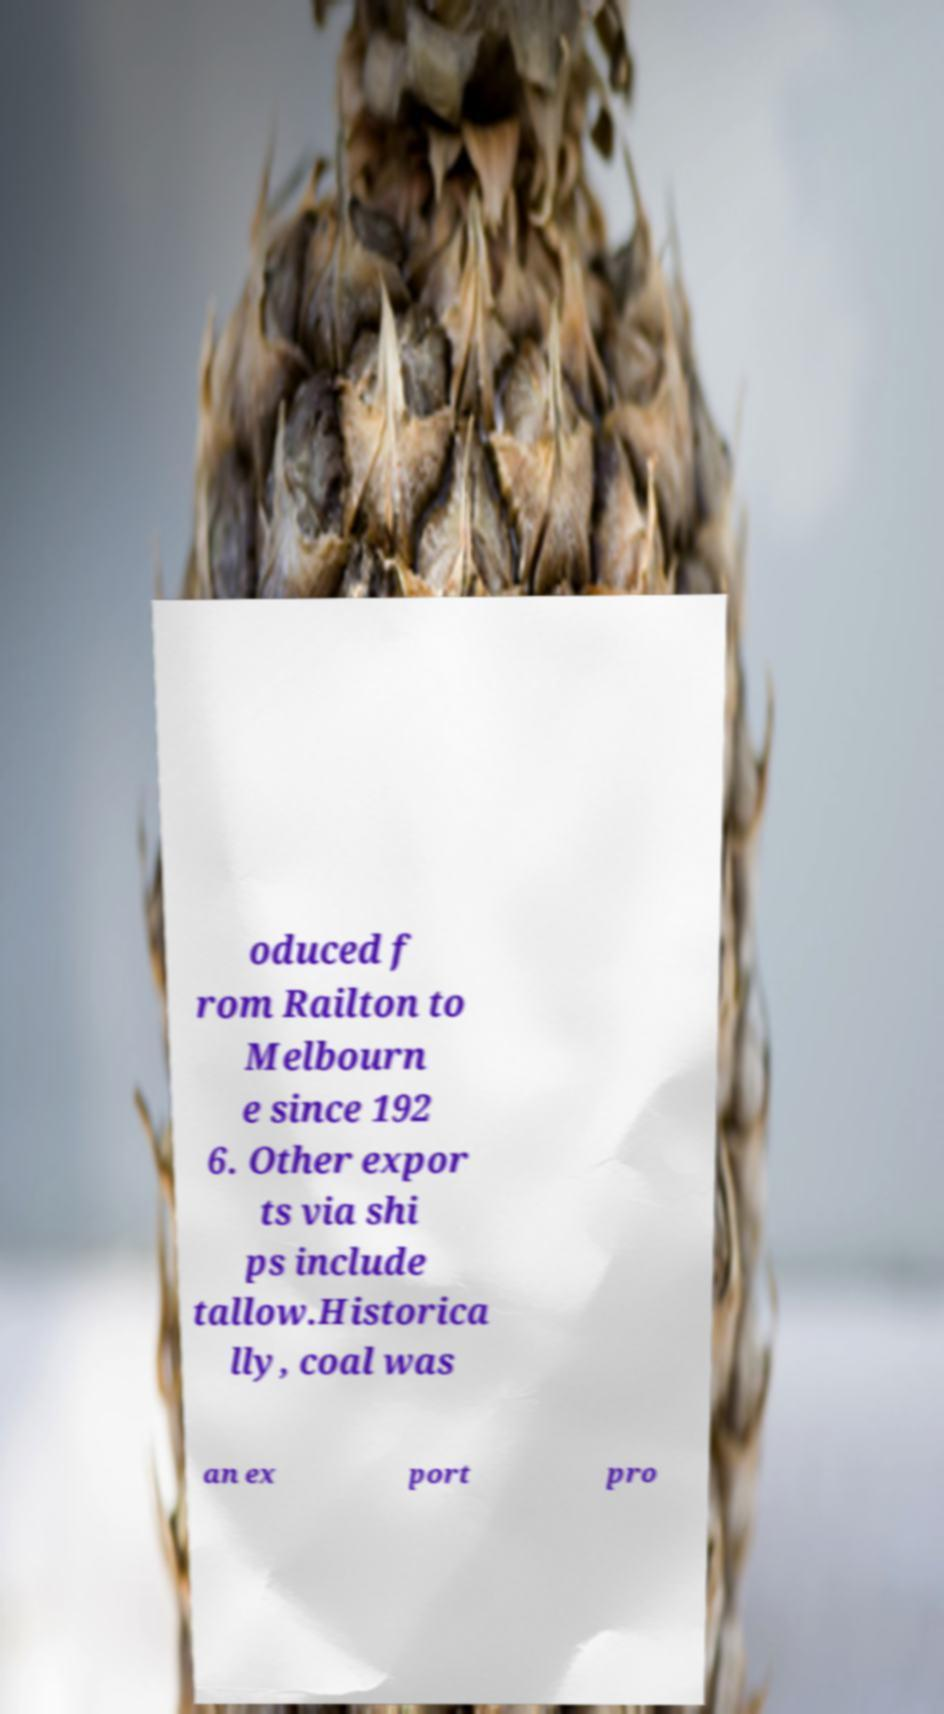Please identify and transcribe the text found in this image. oduced f rom Railton to Melbourn e since 192 6. Other expor ts via shi ps include tallow.Historica lly, coal was an ex port pro 